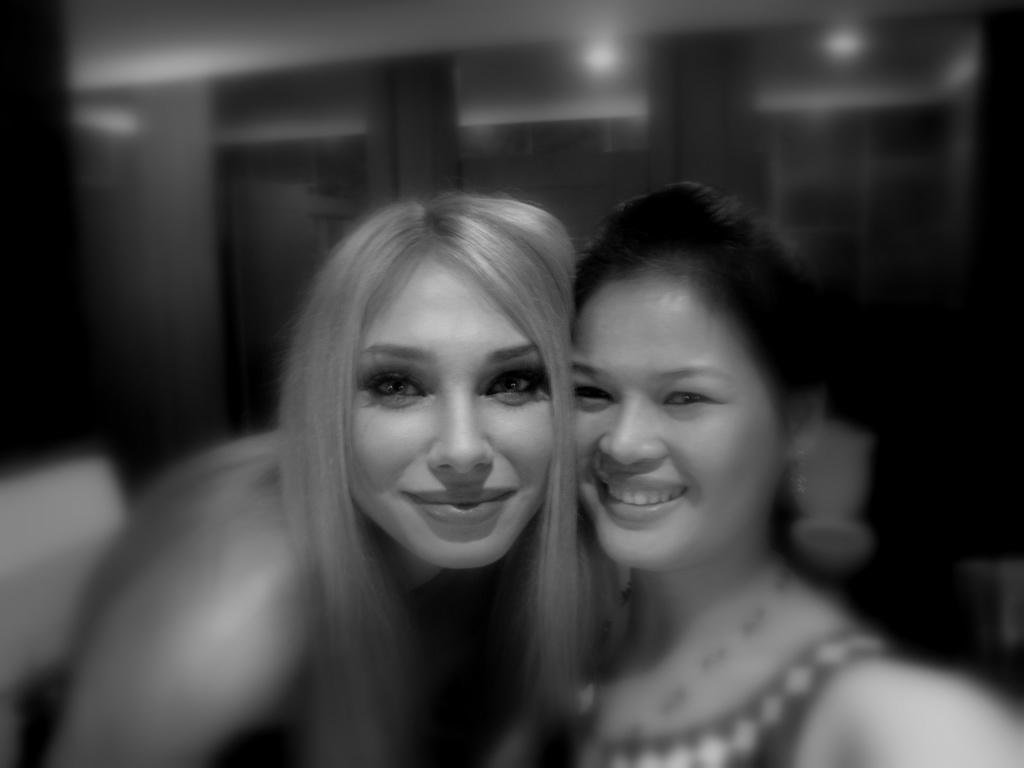What is the color scheme of the image? The image is black and white. How many people are in the image? There are two girls in the image. What is the facial expression of the girls? The girls are smiling. How are the girls connected in the image? The girls are attached to each other. What can be observed about the background of the image? The background of the image is blurry. What type of fuel is being used by the representative in the cave in the image? There is no representative or cave present in the image; it features two girls who are smiling and attached to each other in a black and white setting with a blurry background. 